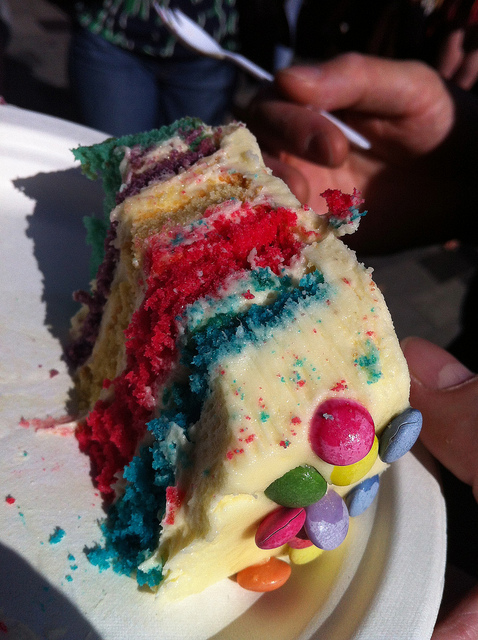<image>What utensil is inside the cake? I don't know if there is any utensil inside the cake. It could be a spoon, fork or nothing. What utensil is inside the cake? I am not sure what utensil is inside the cake. It can be seen 'spoon' or 'fork'. 